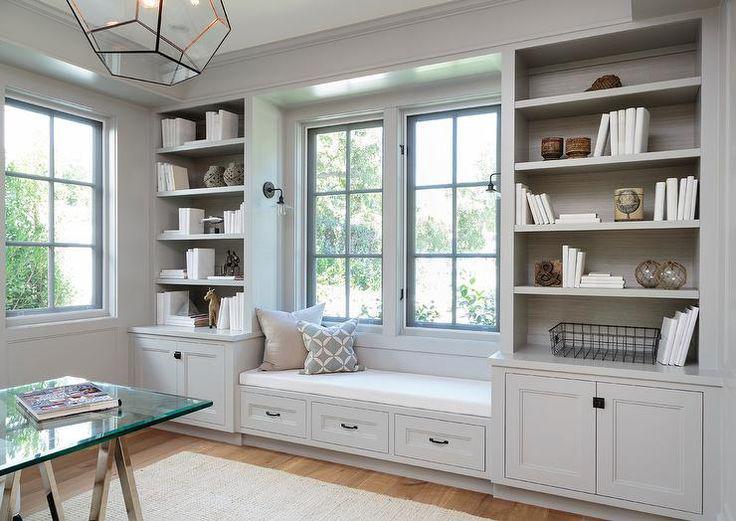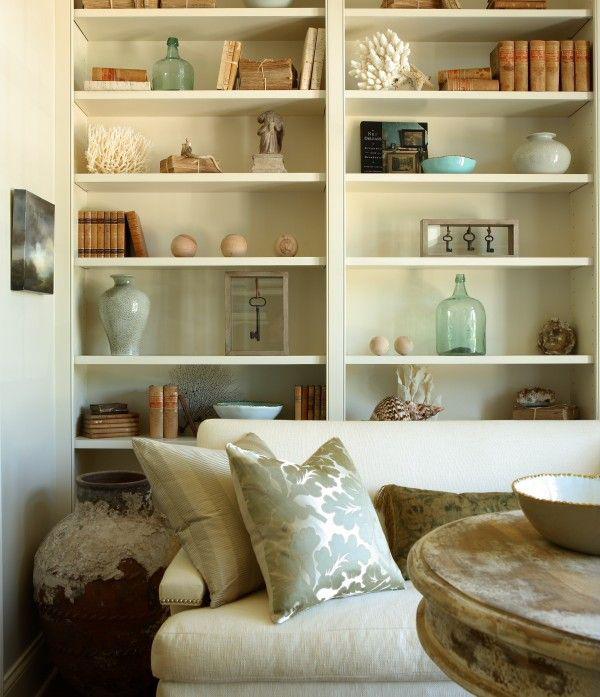The first image is the image on the left, the second image is the image on the right. Evaluate the accuracy of this statement regarding the images: "A television hangs over the mantle in the image on the left.". Is it true? Answer yes or no. No. 